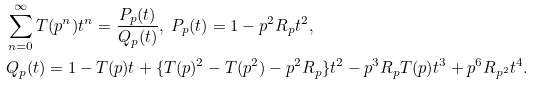<formula> <loc_0><loc_0><loc_500><loc_500>& \sum _ { n = 0 } ^ { \infty } T ( p ^ { n } ) t ^ { n } = \frac { P _ { p } ( t ) } { Q _ { p } ( t ) } , \ P _ { p } ( t ) = 1 - p ^ { 2 } R _ { p } t ^ { 2 } , \\ & Q _ { p } ( t ) = 1 - T ( p ) t + \{ T ( p ) ^ { 2 } - T ( p ^ { 2 } ) - p ^ { 2 } R _ { p } \} t ^ { 2 } - p ^ { 3 } R _ { p } T ( p ) t ^ { 3 } + p ^ { 6 } R _ { p ^ { 2 } } t ^ { 4 } .</formula> 